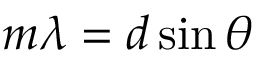Convert formula to latex. <formula><loc_0><loc_0><loc_500><loc_500>m \lambda = d \sin \theta</formula> 